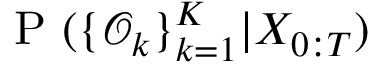<formula> <loc_0><loc_0><loc_500><loc_500>P ( \{ \mathcal { O } _ { k } \} _ { k = 1 } ^ { K } | X _ { 0 \colon T } )</formula> 